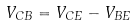<formula> <loc_0><loc_0><loc_500><loc_500>V _ { C B } = V _ { C E } - V _ { B E }</formula> 